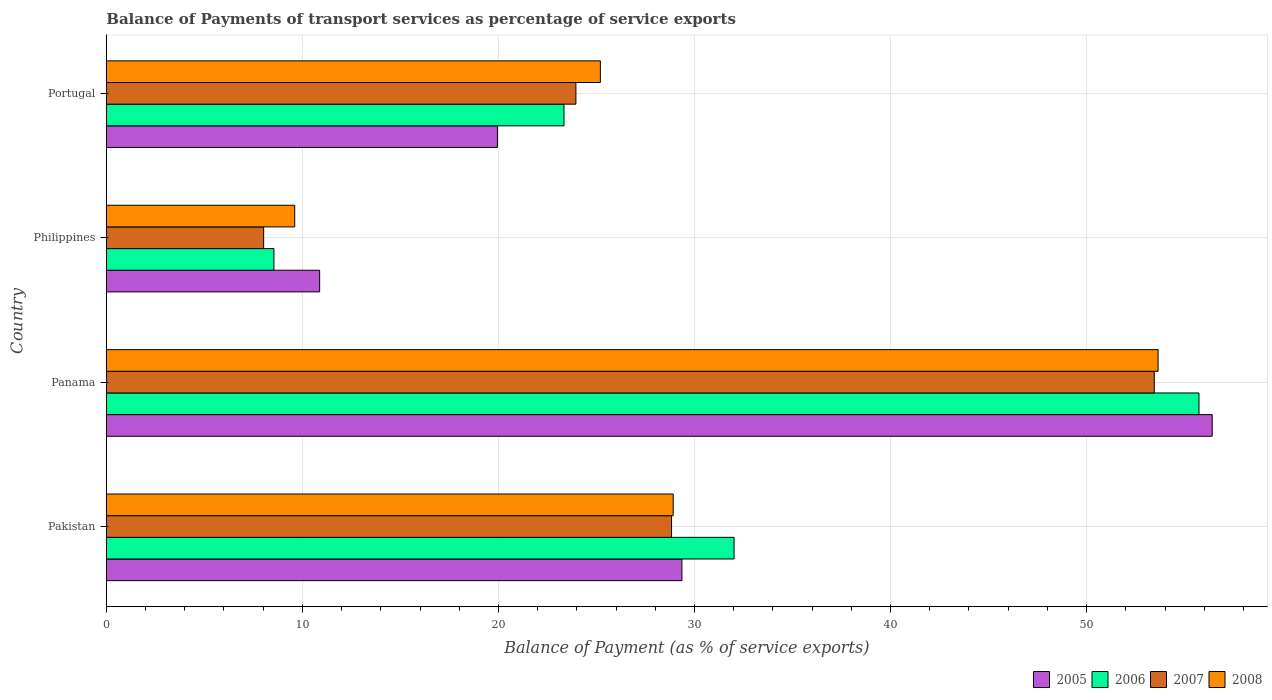How many groups of bars are there?
Your answer should be compact. 4. Are the number of bars per tick equal to the number of legend labels?
Provide a succinct answer. Yes. How many bars are there on the 3rd tick from the top?
Provide a succinct answer. 4. How many bars are there on the 2nd tick from the bottom?
Offer a terse response. 4. What is the balance of payments of transport services in 2006 in Philippines?
Offer a terse response. 8.55. Across all countries, what is the maximum balance of payments of transport services in 2007?
Make the answer very short. 53.45. Across all countries, what is the minimum balance of payments of transport services in 2006?
Make the answer very short. 8.55. In which country was the balance of payments of transport services in 2006 maximum?
Your answer should be compact. Panama. What is the total balance of payments of transport services in 2007 in the graph?
Make the answer very short. 114.26. What is the difference between the balance of payments of transport services in 2008 in Pakistan and that in Philippines?
Keep it short and to the point. 19.31. What is the difference between the balance of payments of transport services in 2008 in Panama and the balance of payments of transport services in 2007 in Philippines?
Ensure brevity in your answer.  45.62. What is the average balance of payments of transport services in 2005 per country?
Ensure brevity in your answer.  29.15. What is the difference between the balance of payments of transport services in 2006 and balance of payments of transport services in 2005 in Panama?
Offer a terse response. -0.67. What is the ratio of the balance of payments of transport services in 2007 in Pakistan to that in Portugal?
Provide a succinct answer. 1.2. Is the balance of payments of transport services in 2007 in Panama less than that in Philippines?
Provide a succinct answer. No. Is the difference between the balance of payments of transport services in 2006 in Panama and Portugal greater than the difference between the balance of payments of transport services in 2005 in Panama and Portugal?
Keep it short and to the point. No. What is the difference between the highest and the second highest balance of payments of transport services in 2008?
Your answer should be compact. 24.73. What is the difference between the highest and the lowest balance of payments of transport services in 2005?
Your response must be concise. 45.53. What does the 4th bar from the top in Philippines represents?
Provide a short and direct response. 2005. Is it the case that in every country, the sum of the balance of payments of transport services in 2008 and balance of payments of transport services in 2007 is greater than the balance of payments of transport services in 2006?
Give a very brief answer. Yes. Are all the bars in the graph horizontal?
Offer a very short reply. Yes. Does the graph contain any zero values?
Make the answer very short. No. Where does the legend appear in the graph?
Make the answer very short. Bottom right. How many legend labels are there?
Provide a succinct answer. 4. What is the title of the graph?
Provide a succinct answer. Balance of Payments of transport services as percentage of service exports. Does "1962" appear as one of the legend labels in the graph?
Provide a short and direct response. No. What is the label or title of the X-axis?
Provide a short and direct response. Balance of Payment (as % of service exports). What is the Balance of Payment (as % of service exports) of 2005 in Pakistan?
Offer a terse response. 29.36. What is the Balance of Payment (as % of service exports) of 2006 in Pakistan?
Provide a succinct answer. 32.02. What is the Balance of Payment (as % of service exports) in 2007 in Pakistan?
Offer a terse response. 28.83. What is the Balance of Payment (as % of service exports) in 2008 in Pakistan?
Offer a very short reply. 28.91. What is the Balance of Payment (as % of service exports) of 2005 in Panama?
Give a very brief answer. 56.41. What is the Balance of Payment (as % of service exports) in 2006 in Panama?
Make the answer very short. 55.73. What is the Balance of Payment (as % of service exports) of 2007 in Panama?
Keep it short and to the point. 53.45. What is the Balance of Payment (as % of service exports) in 2008 in Panama?
Give a very brief answer. 53.65. What is the Balance of Payment (as % of service exports) of 2005 in Philippines?
Your response must be concise. 10.88. What is the Balance of Payment (as % of service exports) in 2006 in Philippines?
Your response must be concise. 8.55. What is the Balance of Payment (as % of service exports) of 2007 in Philippines?
Provide a short and direct response. 8.02. What is the Balance of Payment (as % of service exports) of 2008 in Philippines?
Give a very brief answer. 9.61. What is the Balance of Payment (as % of service exports) in 2005 in Portugal?
Offer a very short reply. 19.95. What is the Balance of Payment (as % of service exports) of 2006 in Portugal?
Ensure brevity in your answer.  23.34. What is the Balance of Payment (as % of service exports) in 2007 in Portugal?
Your answer should be compact. 23.95. What is the Balance of Payment (as % of service exports) of 2008 in Portugal?
Provide a short and direct response. 25.2. Across all countries, what is the maximum Balance of Payment (as % of service exports) in 2005?
Give a very brief answer. 56.41. Across all countries, what is the maximum Balance of Payment (as % of service exports) of 2006?
Give a very brief answer. 55.73. Across all countries, what is the maximum Balance of Payment (as % of service exports) of 2007?
Your response must be concise. 53.45. Across all countries, what is the maximum Balance of Payment (as % of service exports) in 2008?
Your answer should be very brief. 53.65. Across all countries, what is the minimum Balance of Payment (as % of service exports) in 2005?
Offer a very short reply. 10.88. Across all countries, what is the minimum Balance of Payment (as % of service exports) in 2006?
Keep it short and to the point. 8.55. Across all countries, what is the minimum Balance of Payment (as % of service exports) of 2007?
Your answer should be very brief. 8.02. Across all countries, what is the minimum Balance of Payment (as % of service exports) of 2008?
Your answer should be very brief. 9.61. What is the total Balance of Payment (as % of service exports) of 2005 in the graph?
Make the answer very short. 116.6. What is the total Balance of Payment (as % of service exports) in 2006 in the graph?
Keep it short and to the point. 119.64. What is the total Balance of Payment (as % of service exports) of 2007 in the graph?
Your answer should be compact. 114.26. What is the total Balance of Payment (as % of service exports) of 2008 in the graph?
Your response must be concise. 117.37. What is the difference between the Balance of Payment (as % of service exports) in 2005 in Pakistan and that in Panama?
Offer a very short reply. -27.05. What is the difference between the Balance of Payment (as % of service exports) of 2006 in Pakistan and that in Panama?
Ensure brevity in your answer.  -23.71. What is the difference between the Balance of Payment (as % of service exports) of 2007 in Pakistan and that in Panama?
Make the answer very short. -24.62. What is the difference between the Balance of Payment (as % of service exports) in 2008 in Pakistan and that in Panama?
Your answer should be very brief. -24.73. What is the difference between the Balance of Payment (as % of service exports) of 2005 in Pakistan and that in Philippines?
Give a very brief answer. 18.48. What is the difference between the Balance of Payment (as % of service exports) of 2006 in Pakistan and that in Philippines?
Your response must be concise. 23.47. What is the difference between the Balance of Payment (as % of service exports) in 2007 in Pakistan and that in Philippines?
Offer a terse response. 20.81. What is the difference between the Balance of Payment (as % of service exports) in 2008 in Pakistan and that in Philippines?
Your answer should be very brief. 19.31. What is the difference between the Balance of Payment (as % of service exports) of 2005 in Pakistan and that in Portugal?
Ensure brevity in your answer.  9.41. What is the difference between the Balance of Payment (as % of service exports) of 2006 in Pakistan and that in Portugal?
Your answer should be compact. 8.68. What is the difference between the Balance of Payment (as % of service exports) in 2007 in Pakistan and that in Portugal?
Your response must be concise. 4.88. What is the difference between the Balance of Payment (as % of service exports) of 2008 in Pakistan and that in Portugal?
Offer a terse response. 3.71. What is the difference between the Balance of Payment (as % of service exports) in 2005 in Panama and that in Philippines?
Ensure brevity in your answer.  45.53. What is the difference between the Balance of Payment (as % of service exports) of 2006 in Panama and that in Philippines?
Make the answer very short. 47.19. What is the difference between the Balance of Payment (as % of service exports) of 2007 in Panama and that in Philippines?
Keep it short and to the point. 45.43. What is the difference between the Balance of Payment (as % of service exports) of 2008 in Panama and that in Philippines?
Your answer should be compact. 44.04. What is the difference between the Balance of Payment (as % of service exports) of 2005 in Panama and that in Portugal?
Your answer should be very brief. 36.46. What is the difference between the Balance of Payment (as % of service exports) of 2006 in Panama and that in Portugal?
Give a very brief answer. 32.39. What is the difference between the Balance of Payment (as % of service exports) of 2007 in Panama and that in Portugal?
Make the answer very short. 29.5. What is the difference between the Balance of Payment (as % of service exports) of 2008 in Panama and that in Portugal?
Ensure brevity in your answer.  28.45. What is the difference between the Balance of Payment (as % of service exports) of 2005 in Philippines and that in Portugal?
Give a very brief answer. -9.07. What is the difference between the Balance of Payment (as % of service exports) in 2006 in Philippines and that in Portugal?
Make the answer very short. -14.8. What is the difference between the Balance of Payment (as % of service exports) of 2007 in Philippines and that in Portugal?
Your answer should be compact. -15.93. What is the difference between the Balance of Payment (as % of service exports) of 2008 in Philippines and that in Portugal?
Your response must be concise. -15.59. What is the difference between the Balance of Payment (as % of service exports) in 2005 in Pakistan and the Balance of Payment (as % of service exports) in 2006 in Panama?
Ensure brevity in your answer.  -26.37. What is the difference between the Balance of Payment (as % of service exports) in 2005 in Pakistan and the Balance of Payment (as % of service exports) in 2007 in Panama?
Make the answer very short. -24.09. What is the difference between the Balance of Payment (as % of service exports) of 2005 in Pakistan and the Balance of Payment (as % of service exports) of 2008 in Panama?
Keep it short and to the point. -24.29. What is the difference between the Balance of Payment (as % of service exports) of 2006 in Pakistan and the Balance of Payment (as % of service exports) of 2007 in Panama?
Your answer should be very brief. -21.43. What is the difference between the Balance of Payment (as % of service exports) in 2006 in Pakistan and the Balance of Payment (as % of service exports) in 2008 in Panama?
Keep it short and to the point. -21.63. What is the difference between the Balance of Payment (as % of service exports) of 2007 in Pakistan and the Balance of Payment (as % of service exports) of 2008 in Panama?
Give a very brief answer. -24.82. What is the difference between the Balance of Payment (as % of service exports) of 2005 in Pakistan and the Balance of Payment (as % of service exports) of 2006 in Philippines?
Make the answer very short. 20.81. What is the difference between the Balance of Payment (as % of service exports) of 2005 in Pakistan and the Balance of Payment (as % of service exports) of 2007 in Philippines?
Keep it short and to the point. 21.33. What is the difference between the Balance of Payment (as % of service exports) of 2005 in Pakistan and the Balance of Payment (as % of service exports) of 2008 in Philippines?
Give a very brief answer. 19.75. What is the difference between the Balance of Payment (as % of service exports) of 2006 in Pakistan and the Balance of Payment (as % of service exports) of 2007 in Philippines?
Your answer should be very brief. 24. What is the difference between the Balance of Payment (as % of service exports) of 2006 in Pakistan and the Balance of Payment (as % of service exports) of 2008 in Philippines?
Provide a succinct answer. 22.41. What is the difference between the Balance of Payment (as % of service exports) of 2007 in Pakistan and the Balance of Payment (as % of service exports) of 2008 in Philippines?
Your answer should be compact. 19.22. What is the difference between the Balance of Payment (as % of service exports) of 2005 in Pakistan and the Balance of Payment (as % of service exports) of 2006 in Portugal?
Your answer should be compact. 6.02. What is the difference between the Balance of Payment (as % of service exports) of 2005 in Pakistan and the Balance of Payment (as % of service exports) of 2007 in Portugal?
Ensure brevity in your answer.  5.41. What is the difference between the Balance of Payment (as % of service exports) of 2005 in Pakistan and the Balance of Payment (as % of service exports) of 2008 in Portugal?
Offer a very short reply. 4.16. What is the difference between the Balance of Payment (as % of service exports) in 2006 in Pakistan and the Balance of Payment (as % of service exports) in 2007 in Portugal?
Ensure brevity in your answer.  8.07. What is the difference between the Balance of Payment (as % of service exports) in 2006 in Pakistan and the Balance of Payment (as % of service exports) in 2008 in Portugal?
Your answer should be compact. 6.82. What is the difference between the Balance of Payment (as % of service exports) in 2007 in Pakistan and the Balance of Payment (as % of service exports) in 2008 in Portugal?
Provide a succinct answer. 3.63. What is the difference between the Balance of Payment (as % of service exports) of 2005 in Panama and the Balance of Payment (as % of service exports) of 2006 in Philippines?
Your response must be concise. 47.86. What is the difference between the Balance of Payment (as % of service exports) of 2005 in Panama and the Balance of Payment (as % of service exports) of 2007 in Philippines?
Offer a very short reply. 48.38. What is the difference between the Balance of Payment (as % of service exports) of 2005 in Panama and the Balance of Payment (as % of service exports) of 2008 in Philippines?
Your response must be concise. 46.8. What is the difference between the Balance of Payment (as % of service exports) of 2006 in Panama and the Balance of Payment (as % of service exports) of 2007 in Philippines?
Offer a terse response. 47.71. What is the difference between the Balance of Payment (as % of service exports) of 2006 in Panama and the Balance of Payment (as % of service exports) of 2008 in Philippines?
Provide a short and direct response. 46.12. What is the difference between the Balance of Payment (as % of service exports) of 2007 in Panama and the Balance of Payment (as % of service exports) of 2008 in Philippines?
Provide a short and direct response. 43.84. What is the difference between the Balance of Payment (as % of service exports) of 2005 in Panama and the Balance of Payment (as % of service exports) of 2006 in Portugal?
Offer a terse response. 33.06. What is the difference between the Balance of Payment (as % of service exports) of 2005 in Panama and the Balance of Payment (as % of service exports) of 2007 in Portugal?
Provide a succinct answer. 32.46. What is the difference between the Balance of Payment (as % of service exports) of 2005 in Panama and the Balance of Payment (as % of service exports) of 2008 in Portugal?
Your answer should be very brief. 31.21. What is the difference between the Balance of Payment (as % of service exports) of 2006 in Panama and the Balance of Payment (as % of service exports) of 2007 in Portugal?
Offer a terse response. 31.78. What is the difference between the Balance of Payment (as % of service exports) of 2006 in Panama and the Balance of Payment (as % of service exports) of 2008 in Portugal?
Provide a short and direct response. 30.53. What is the difference between the Balance of Payment (as % of service exports) in 2007 in Panama and the Balance of Payment (as % of service exports) in 2008 in Portugal?
Provide a short and direct response. 28.25. What is the difference between the Balance of Payment (as % of service exports) in 2005 in Philippines and the Balance of Payment (as % of service exports) in 2006 in Portugal?
Your answer should be very brief. -12.46. What is the difference between the Balance of Payment (as % of service exports) in 2005 in Philippines and the Balance of Payment (as % of service exports) in 2007 in Portugal?
Offer a terse response. -13.07. What is the difference between the Balance of Payment (as % of service exports) in 2005 in Philippines and the Balance of Payment (as % of service exports) in 2008 in Portugal?
Provide a succinct answer. -14.32. What is the difference between the Balance of Payment (as % of service exports) in 2006 in Philippines and the Balance of Payment (as % of service exports) in 2007 in Portugal?
Make the answer very short. -15.4. What is the difference between the Balance of Payment (as % of service exports) in 2006 in Philippines and the Balance of Payment (as % of service exports) in 2008 in Portugal?
Make the answer very short. -16.65. What is the difference between the Balance of Payment (as % of service exports) in 2007 in Philippines and the Balance of Payment (as % of service exports) in 2008 in Portugal?
Keep it short and to the point. -17.18. What is the average Balance of Payment (as % of service exports) in 2005 per country?
Provide a succinct answer. 29.15. What is the average Balance of Payment (as % of service exports) in 2006 per country?
Your answer should be very brief. 29.91. What is the average Balance of Payment (as % of service exports) of 2007 per country?
Give a very brief answer. 28.57. What is the average Balance of Payment (as % of service exports) of 2008 per country?
Make the answer very short. 29.34. What is the difference between the Balance of Payment (as % of service exports) in 2005 and Balance of Payment (as % of service exports) in 2006 in Pakistan?
Provide a short and direct response. -2.66. What is the difference between the Balance of Payment (as % of service exports) in 2005 and Balance of Payment (as % of service exports) in 2007 in Pakistan?
Offer a terse response. 0.53. What is the difference between the Balance of Payment (as % of service exports) in 2005 and Balance of Payment (as % of service exports) in 2008 in Pakistan?
Make the answer very short. 0.44. What is the difference between the Balance of Payment (as % of service exports) of 2006 and Balance of Payment (as % of service exports) of 2007 in Pakistan?
Your answer should be very brief. 3.19. What is the difference between the Balance of Payment (as % of service exports) in 2006 and Balance of Payment (as % of service exports) in 2008 in Pakistan?
Ensure brevity in your answer.  3.1. What is the difference between the Balance of Payment (as % of service exports) in 2007 and Balance of Payment (as % of service exports) in 2008 in Pakistan?
Provide a short and direct response. -0.08. What is the difference between the Balance of Payment (as % of service exports) of 2005 and Balance of Payment (as % of service exports) of 2006 in Panama?
Make the answer very short. 0.67. What is the difference between the Balance of Payment (as % of service exports) of 2005 and Balance of Payment (as % of service exports) of 2007 in Panama?
Give a very brief answer. 2.95. What is the difference between the Balance of Payment (as % of service exports) in 2005 and Balance of Payment (as % of service exports) in 2008 in Panama?
Offer a terse response. 2.76. What is the difference between the Balance of Payment (as % of service exports) of 2006 and Balance of Payment (as % of service exports) of 2007 in Panama?
Provide a succinct answer. 2.28. What is the difference between the Balance of Payment (as % of service exports) in 2006 and Balance of Payment (as % of service exports) in 2008 in Panama?
Your response must be concise. 2.09. What is the difference between the Balance of Payment (as % of service exports) of 2007 and Balance of Payment (as % of service exports) of 2008 in Panama?
Ensure brevity in your answer.  -0.19. What is the difference between the Balance of Payment (as % of service exports) of 2005 and Balance of Payment (as % of service exports) of 2006 in Philippines?
Your response must be concise. 2.33. What is the difference between the Balance of Payment (as % of service exports) of 2005 and Balance of Payment (as % of service exports) of 2007 in Philippines?
Make the answer very short. 2.86. What is the difference between the Balance of Payment (as % of service exports) of 2005 and Balance of Payment (as % of service exports) of 2008 in Philippines?
Your answer should be very brief. 1.27. What is the difference between the Balance of Payment (as % of service exports) of 2006 and Balance of Payment (as % of service exports) of 2007 in Philippines?
Offer a very short reply. 0.52. What is the difference between the Balance of Payment (as % of service exports) of 2006 and Balance of Payment (as % of service exports) of 2008 in Philippines?
Your answer should be compact. -1.06. What is the difference between the Balance of Payment (as % of service exports) in 2007 and Balance of Payment (as % of service exports) in 2008 in Philippines?
Provide a succinct answer. -1.58. What is the difference between the Balance of Payment (as % of service exports) in 2005 and Balance of Payment (as % of service exports) in 2006 in Portugal?
Offer a very short reply. -3.4. What is the difference between the Balance of Payment (as % of service exports) of 2005 and Balance of Payment (as % of service exports) of 2007 in Portugal?
Offer a terse response. -4. What is the difference between the Balance of Payment (as % of service exports) of 2005 and Balance of Payment (as % of service exports) of 2008 in Portugal?
Offer a terse response. -5.25. What is the difference between the Balance of Payment (as % of service exports) in 2006 and Balance of Payment (as % of service exports) in 2007 in Portugal?
Make the answer very short. -0.61. What is the difference between the Balance of Payment (as % of service exports) in 2006 and Balance of Payment (as % of service exports) in 2008 in Portugal?
Provide a succinct answer. -1.86. What is the difference between the Balance of Payment (as % of service exports) of 2007 and Balance of Payment (as % of service exports) of 2008 in Portugal?
Keep it short and to the point. -1.25. What is the ratio of the Balance of Payment (as % of service exports) of 2005 in Pakistan to that in Panama?
Your answer should be very brief. 0.52. What is the ratio of the Balance of Payment (as % of service exports) of 2006 in Pakistan to that in Panama?
Offer a very short reply. 0.57. What is the ratio of the Balance of Payment (as % of service exports) in 2007 in Pakistan to that in Panama?
Your response must be concise. 0.54. What is the ratio of the Balance of Payment (as % of service exports) of 2008 in Pakistan to that in Panama?
Offer a very short reply. 0.54. What is the ratio of the Balance of Payment (as % of service exports) in 2005 in Pakistan to that in Philippines?
Make the answer very short. 2.7. What is the ratio of the Balance of Payment (as % of service exports) of 2006 in Pakistan to that in Philippines?
Your answer should be compact. 3.75. What is the ratio of the Balance of Payment (as % of service exports) in 2007 in Pakistan to that in Philippines?
Your answer should be very brief. 3.59. What is the ratio of the Balance of Payment (as % of service exports) in 2008 in Pakistan to that in Philippines?
Offer a very short reply. 3.01. What is the ratio of the Balance of Payment (as % of service exports) of 2005 in Pakistan to that in Portugal?
Make the answer very short. 1.47. What is the ratio of the Balance of Payment (as % of service exports) of 2006 in Pakistan to that in Portugal?
Offer a very short reply. 1.37. What is the ratio of the Balance of Payment (as % of service exports) of 2007 in Pakistan to that in Portugal?
Your answer should be compact. 1.2. What is the ratio of the Balance of Payment (as % of service exports) in 2008 in Pakistan to that in Portugal?
Provide a succinct answer. 1.15. What is the ratio of the Balance of Payment (as % of service exports) of 2005 in Panama to that in Philippines?
Provide a succinct answer. 5.18. What is the ratio of the Balance of Payment (as % of service exports) of 2006 in Panama to that in Philippines?
Ensure brevity in your answer.  6.52. What is the ratio of the Balance of Payment (as % of service exports) in 2007 in Panama to that in Philippines?
Keep it short and to the point. 6.66. What is the ratio of the Balance of Payment (as % of service exports) in 2008 in Panama to that in Philippines?
Offer a very short reply. 5.58. What is the ratio of the Balance of Payment (as % of service exports) in 2005 in Panama to that in Portugal?
Keep it short and to the point. 2.83. What is the ratio of the Balance of Payment (as % of service exports) in 2006 in Panama to that in Portugal?
Offer a very short reply. 2.39. What is the ratio of the Balance of Payment (as % of service exports) in 2007 in Panama to that in Portugal?
Provide a short and direct response. 2.23. What is the ratio of the Balance of Payment (as % of service exports) in 2008 in Panama to that in Portugal?
Provide a succinct answer. 2.13. What is the ratio of the Balance of Payment (as % of service exports) in 2005 in Philippines to that in Portugal?
Ensure brevity in your answer.  0.55. What is the ratio of the Balance of Payment (as % of service exports) in 2006 in Philippines to that in Portugal?
Offer a terse response. 0.37. What is the ratio of the Balance of Payment (as % of service exports) in 2007 in Philippines to that in Portugal?
Offer a very short reply. 0.34. What is the ratio of the Balance of Payment (as % of service exports) of 2008 in Philippines to that in Portugal?
Keep it short and to the point. 0.38. What is the difference between the highest and the second highest Balance of Payment (as % of service exports) in 2005?
Keep it short and to the point. 27.05. What is the difference between the highest and the second highest Balance of Payment (as % of service exports) in 2006?
Your answer should be very brief. 23.71. What is the difference between the highest and the second highest Balance of Payment (as % of service exports) in 2007?
Give a very brief answer. 24.62. What is the difference between the highest and the second highest Balance of Payment (as % of service exports) in 2008?
Your answer should be very brief. 24.73. What is the difference between the highest and the lowest Balance of Payment (as % of service exports) in 2005?
Give a very brief answer. 45.53. What is the difference between the highest and the lowest Balance of Payment (as % of service exports) of 2006?
Keep it short and to the point. 47.19. What is the difference between the highest and the lowest Balance of Payment (as % of service exports) of 2007?
Keep it short and to the point. 45.43. What is the difference between the highest and the lowest Balance of Payment (as % of service exports) of 2008?
Provide a succinct answer. 44.04. 